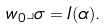<formula> <loc_0><loc_0><loc_500><loc_500>w _ { 0 } \lrcorner \sigma = I ( \alpha ) .</formula> 